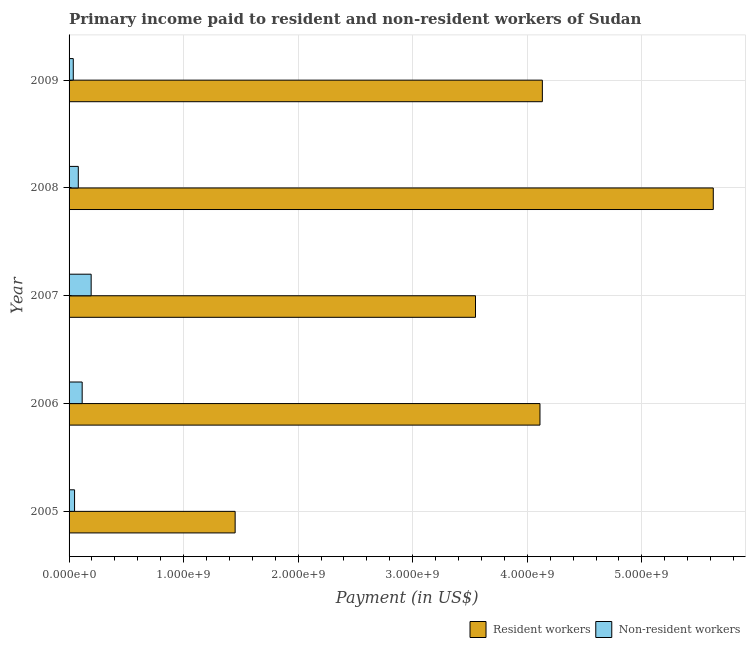How many different coloured bars are there?
Offer a very short reply. 2. Are the number of bars per tick equal to the number of legend labels?
Offer a terse response. Yes. Are the number of bars on each tick of the Y-axis equal?
Provide a short and direct response. Yes. How many bars are there on the 3rd tick from the top?
Offer a terse response. 2. How many bars are there on the 3rd tick from the bottom?
Keep it short and to the point. 2. What is the payment made to resident workers in 2006?
Keep it short and to the point. 4.11e+09. Across all years, what is the maximum payment made to non-resident workers?
Make the answer very short. 1.93e+08. Across all years, what is the minimum payment made to resident workers?
Give a very brief answer. 1.45e+09. In which year was the payment made to resident workers minimum?
Ensure brevity in your answer.  2005. What is the total payment made to resident workers in the graph?
Offer a very short reply. 1.89e+1. What is the difference between the payment made to non-resident workers in 2006 and that in 2009?
Provide a succinct answer. 7.76e+07. What is the difference between the payment made to non-resident workers in 2009 and the payment made to resident workers in 2005?
Keep it short and to the point. -1.41e+09. What is the average payment made to resident workers per year?
Provide a succinct answer. 3.77e+09. In the year 2005, what is the difference between the payment made to non-resident workers and payment made to resident workers?
Your answer should be compact. -1.40e+09. In how many years, is the payment made to resident workers greater than 5400000000 US$?
Give a very brief answer. 1. What is the ratio of the payment made to non-resident workers in 2005 to that in 2009?
Offer a very short reply. 1.3. Is the difference between the payment made to non-resident workers in 2005 and 2006 greater than the difference between the payment made to resident workers in 2005 and 2006?
Your answer should be compact. Yes. What is the difference between the highest and the second highest payment made to non-resident workers?
Ensure brevity in your answer.  7.85e+07. What is the difference between the highest and the lowest payment made to resident workers?
Ensure brevity in your answer.  4.17e+09. In how many years, is the payment made to non-resident workers greater than the average payment made to non-resident workers taken over all years?
Your response must be concise. 2. What does the 2nd bar from the top in 2007 represents?
Your answer should be compact. Resident workers. What does the 2nd bar from the bottom in 2006 represents?
Your response must be concise. Non-resident workers. Are all the bars in the graph horizontal?
Your answer should be compact. Yes. How many years are there in the graph?
Provide a succinct answer. 5. What is the difference between two consecutive major ticks on the X-axis?
Ensure brevity in your answer.  1.00e+09. Does the graph contain any zero values?
Offer a terse response. No. Does the graph contain grids?
Give a very brief answer. Yes. Where does the legend appear in the graph?
Give a very brief answer. Bottom right. How many legend labels are there?
Give a very brief answer. 2. How are the legend labels stacked?
Provide a succinct answer. Horizontal. What is the title of the graph?
Your answer should be very brief. Primary income paid to resident and non-resident workers of Sudan. What is the label or title of the X-axis?
Offer a very short reply. Payment (in US$). What is the label or title of the Y-axis?
Make the answer very short. Year. What is the Payment (in US$) of Resident workers in 2005?
Provide a short and direct response. 1.45e+09. What is the Payment (in US$) in Non-resident workers in 2005?
Give a very brief answer. 4.79e+07. What is the Payment (in US$) in Resident workers in 2006?
Your answer should be compact. 4.11e+09. What is the Payment (in US$) of Non-resident workers in 2006?
Give a very brief answer. 1.14e+08. What is the Payment (in US$) in Resident workers in 2007?
Give a very brief answer. 3.55e+09. What is the Payment (in US$) in Non-resident workers in 2007?
Your answer should be very brief. 1.93e+08. What is the Payment (in US$) of Resident workers in 2008?
Your response must be concise. 5.62e+09. What is the Payment (in US$) of Non-resident workers in 2008?
Make the answer very short. 8.05e+07. What is the Payment (in US$) in Resident workers in 2009?
Ensure brevity in your answer.  4.13e+09. What is the Payment (in US$) in Non-resident workers in 2009?
Give a very brief answer. 3.67e+07. Across all years, what is the maximum Payment (in US$) of Resident workers?
Keep it short and to the point. 5.62e+09. Across all years, what is the maximum Payment (in US$) in Non-resident workers?
Offer a very short reply. 1.93e+08. Across all years, what is the minimum Payment (in US$) of Resident workers?
Offer a very short reply. 1.45e+09. Across all years, what is the minimum Payment (in US$) of Non-resident workers?
Keep it short and to the point. 3.67e+07. What is the total Payment (in US$) in Resident workers in the graph?
Provide a short and direct response. 1.89e+1. What is the total Payment (in US$) of Non-resident workers in the graph?
Provide a succinct answer. 4.72e+08. What is the difference between the Payment (in US$) in Resident workers in 2005 and that in 2006?
Give a very brief answer. -2.66e+09. What is the difference between the Payment (in US$) in Non-resident workers in 2005 and that in 2006?
Your answer should be very brief. -6.65e+07. What is the difference between the Payment (in US$) of Resident workers in 2005 and that in 2007?
Make the answer very short. -2.10e+09. What is the difference between the Payment (in US$) in Non-resident workers in 2005 and that in 2007?
Keep it short and to the point. -1.45e+08. What is the difference between the Payment (in US$) in Resident workers in 2005 and that in 2008?
Your answer should be compact. -4.17e+09. What is the difference between the Payment (in US$) of Non-resident workers in 2005 and that in 2008?
Your answer should be very brief. -3.26e+07. What is the difference between the Payment (in US$) of Resident workers in 2005 and that in 2009?
Keep it short and to the point. -2.68e+09. What is the difference between the Payment (in US$) in Non-resident workers in 2005 and that in 2009?
Make the answer very short. 1.12e+07. What is the difference between the Payment (in US$) in Resident workers in 2006 and that in 2007?
Give a very brief answer. 5.63e+08. What is the difference between the Payment (in US$) in Non-resident workers in 2006 and that in 2007?
Your answer should be very brief. -7.85e+07. What is the difference between the Payment (in US$) of Resident workers in 2006 and that in 2008?
Offer a very short reply. -1.51e+09. What is the difference between the Payment (in US$) of Non-resident workers in 2006 and that in 2008?
Provide a short and direct response. 3.39e+07. What is the difference between the Payment (in US$) in Resident workers in 2006 and that in 2009?
Ensure brevity in your answer.  -2.09e+07. What is the difference between the Payment (in US$) in Non-resident workers in 2006 and that in 2009?
Your answer should be compact. 7.76e+07. What is the difference between the Payment (in US$) of Resident workers in 2007 and that in 2008?
Your answer should be very brief. -2.08e+09. What is the difference between the Payment (in US$) of Non-resident workers in 2007 and that in 2008?
Make the answer very short. 1.12e+08. What is the difference between the Payment (in US$) in Resident workers in 2007 and that in 2009?
Provide a succinct answer. -5.84e+08. What is the difference between the Payment (in US$) of Non-resident workers in 2007 and that in 2009?
Your response must be concise. 1.56e+08. What is the difference between the Payment (in US$) in Resident workers in 2008 and that in 2009?
Provide a succinct answer. 1.49e+09. What is the difference between the Payment (in US$) in Non-resident workers in 2008 and that in 2009?
Your answer should be very brief. 4.38e+07. What is the difference between the Payment (in US$) in Resident workers in 2005 and the Payment (in US$) in Non-resident workers in 2006?
Make the answer very short. 1.34e+09. What is the difference between the Payment (in US$) of Resident workers in 2005 and the Payment (in US$) of Non-resident workers in 2007?
Offer a terse response. 1.26e+09. What is the difference between the Payment (in US$) of Resident workers in 2005 and the Payment (in US$) of Non-resident workers in 2008?
Give a very brief answer. 1.37e+09. What is the difference between the Payment (in US$) of Resident workers in 2005 and the Payment (in US$) of Non-resident workers in 2009?
Provide a succinct answer. 1.41e+09. What is the difference between the Payment (in US$) of Resident workers in 2006 and the Payment (in US$) of Non-resident workers in 2007?
Provide a short and direct response. 3.92e+09. What is the difference between the Payment (in US$) in Resident workers in 2006 and the Payment (in US$) in Non-resident workers in 2008?
Your answer should be compact. 4.03e+09. What is the difference between the Payment (in US$) in Resident workers in 2006 and the Payment (in US$) in Non-resident workers in 2009?
Ensure brevity in your answer.  4.07e+09. What is the difference between the Payment (in US$) of Resident workers in 2007 and the Payment (in US$) of Non-resident workers in 2008?
Keep it short and to the point. 3.47e+09. What is the difference between the Payment (in US$) in Resident workers in 2007 and the Payment (in US$) in Non-resident workers in 2009?
Keep it short and to the point. 3.51e+09. What is the difference between the Payment (in US$) in Resident workers in 2008 and the Payment (in US$) in Non-resident workers in 2009?
Ensure brevity in your answer.  5.59e+09. What is the average Payment (in US$) in Resident workers per year?
Your answer should be very brief. 3.77e+09. What is the average Payment (in US$) of Non-resident workers per year?
Your answer should be compact. 9.45e+07. In the year 2005, what is the difference between the Payment (in US$) in Resident workers and Payment (in US$) in Non-resident workers?
Make the answer very short. 1.40e+09. In the year 2006, what is the difference between the Payment (in US$) in Resident workers and Payment (in US$) in Non-resident workers?
Offer a terse response. 4.00e+09. In the year 2007, what is the difference between the Payment (in US$) in Resident workers and Payment (in US$) in Non-resident workers?
Ensure brevity in your answer.  3.36e+09. In the year 2008, what is the difference between the Payment (in US$) in Resident workers and Payment (in US$) in Non-resident workers?
Make the answer very short. 5.54e+09. In the year 2009, what is the difference between the Payment (in US$) of Resident workers and Payment (in US$) of Non-resident workers?
Offer a very short reply. 4.10e+09. What is the ratio of the Payment (in US$) in Resident workers in 2005 to that in 2006?
Your response must be concise. 0.35. What is the ratio of the Payment (in US$) of Non-resident workers in 2005 to that in 2006?
Your answer should be very brief. 0.42. What is the ratio of the Payment (in US$) in Resident workers in 2005 to that in 2007?
Offer a terse response. 0.41. What is the ratio of the Payment (in US$) in Non-resident workers in 2005 to that in 2007?
Your answer should be very brief. 0.25. What is the ratio of the Payment (in US$) of Resident workers in 2005 to that in 2008?
Your response must be concise. 0.26. What is the ratio of the Payment (in US$) in Non-resident workers in 2005 to that in 2008?
Your response must be concise. 0.6. What is the ratio of the Payment (in US$) in Resident workers in 2005 to that in 2009?
Your response must be concise. 0.35. What is the ratio of the Payment (in US$) of Non-resident workers in 2005 to that in 2009?
Provide a succinct answer. 1.3. What is the ratio of the Payment (in US$) of Resident workers in 2006 to that in 2007?
Offer a very short reply. 1.16. What is the ratio of the Payment (in US$) in Non-resident workers in 2006 to that in 2007?
Offer a terse response. 0.59. What is the ratio of the Payment (in US$) of Resident workers in 2006 to that in 2008?
Your answer should be very brief. 0.73. What is the ratio of the Payment (in US$) of Non-resident workers in 2006 to that in 2008?
Give a very brief answer. 1.42. What is the ratio of the Payment (in US$) of Resident workers in 2006 to that in 2009?
Keep it short and to the point. 0.99. What is the ratio of the Payment (in US$) in Non-resident workers in 2006 to that in 2009?
Your response must be concise. 3.11. What is the ratio of the Payment (in US$) of Resident workers in 2007 to that in 2008?
Provide a succinct answer. 0.63. What is the ratio of the Payment (in US$) of Non-resident workers in 2007 to that in 2008?
Offer a very short reply. 2.4. What is the ratio of the Payment (in US$) of Resident workers in 2007 to that in 2009?
Offer a terse response. 0.86. What is the ratio of the Payment (in US$) of Non-resident workers in 2007 to that in 2009?
Offer a very short reply. 5.25. What is the ratio of the Payment (in US$) in Resident workers in 2008 to that in 2009?
Give a very brief answer. 1.36. What is the ratio of the Payment (in US$) of Non-resident workers in 2008 to that in 2009?
Give a very brief answer. 2.19. What is the difference between the highest and the second highest Payment (in US$) in Resident workers?
Your response must be concise. 1.49e+09. What is the difference between the highest and the second highest Payment (in US$) in Non-resident workers?
Make the answer very short. 7.85e+07. What is the difference between the highest and the lowest Payment (in US$) of Resident workers?
Keep it short and to the point. 4.17e+09. What is the difference between the highest and the lowest Payment (in US$) of Non-resident workers?
Give a very brief answer. 1.56e+08. 